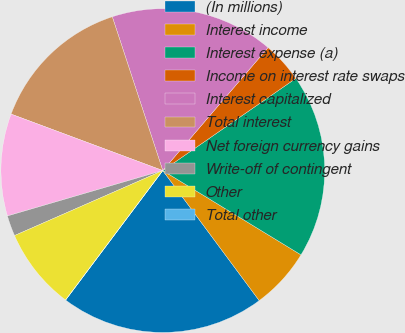Convert chart to OTSL. <chart><loc_0><loc_0><loc_500><loc_500><pie_chart><fcel>(In millions)<fcel>Interest income<fcel>Interest expense (a)<fcel>Income on interest rate swaps<fcel>Interest capitalized<fcel>Total interest<fcel>Net foreign currency gains<fcel>Write-off of contingent<fcel>Other<fcel>Total other<nl><fcel>20.4%<fcel>6.13%<fcel>18.36%<fcel>4.09%<fcel>16.32%<fcel>14.28%<fcel>10.2%<fcel>2.05%<fcel>8.17%<fcel>0.01%<nl></chart> 